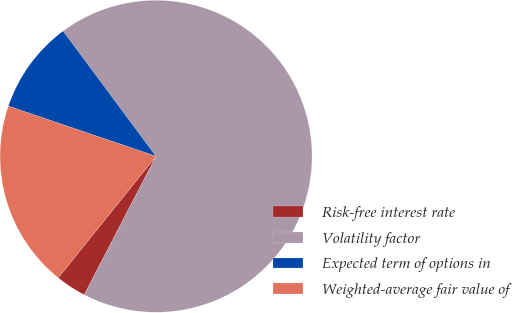Convert chart. <chart><loc_0><loc_0><loc_500><loc_500><pie_chart><fcel>Risk-free interest rate<fcel>Volatility factor<fcel>Expected term of options in<fcel>Weighted-average fair value of<nl><fcel>3.17%<fcel>67.77%<fcel>9.63%<fcel>19.43%<nl></chart> 